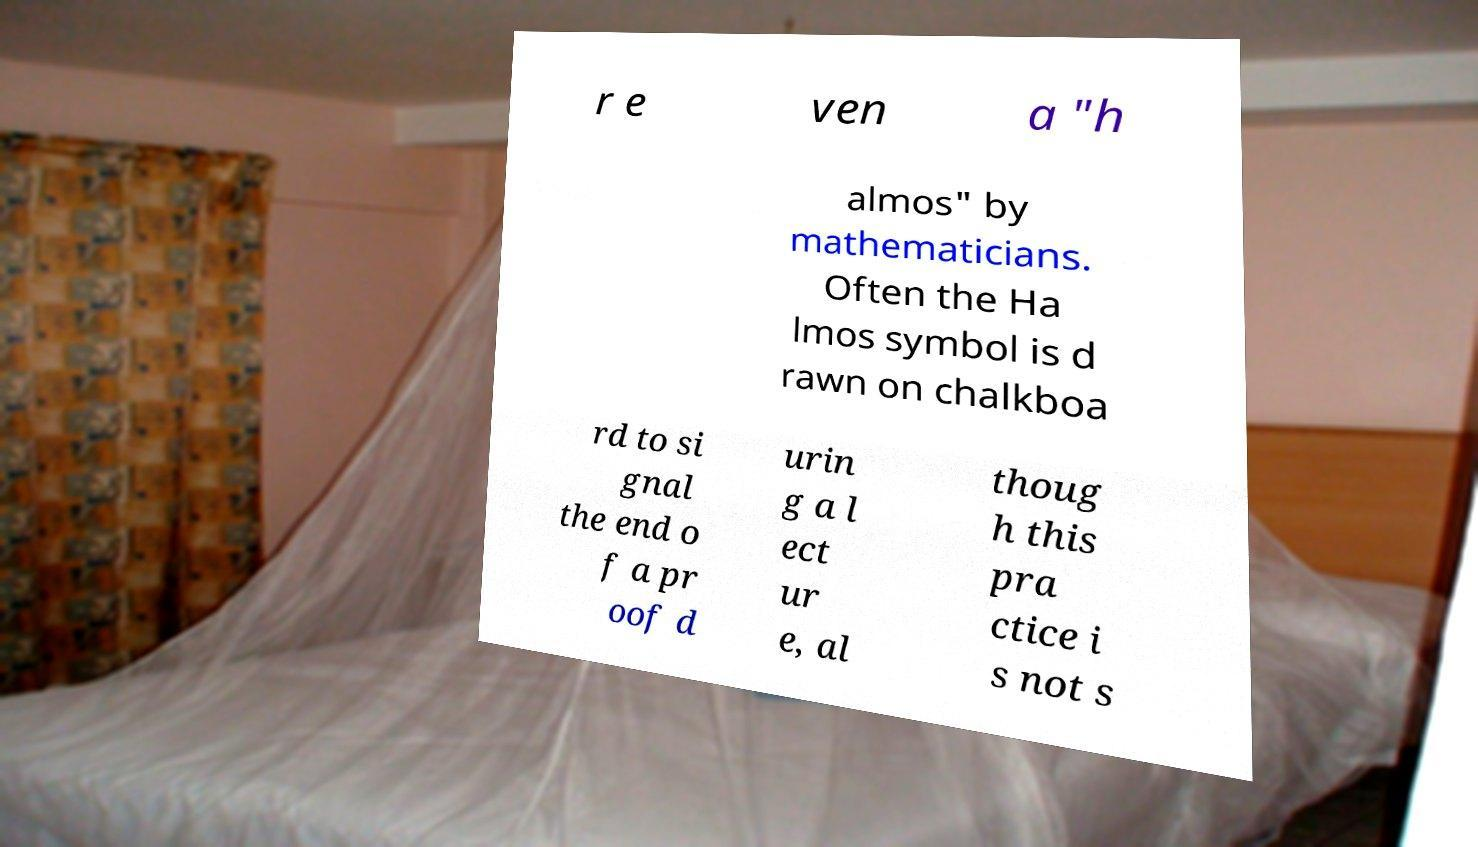Can you read and provide the text displayed in the image?This photo seems to have some interesting text. Can you extract and type it out for me? r e ven a "h almos" by mathematicians. Often the Ha lmos symbol is d rawn on chalkboa rd to si gnal the end o f a pr oof d urin g a l ect ur e, al thoug h this pra ctice i s not s 